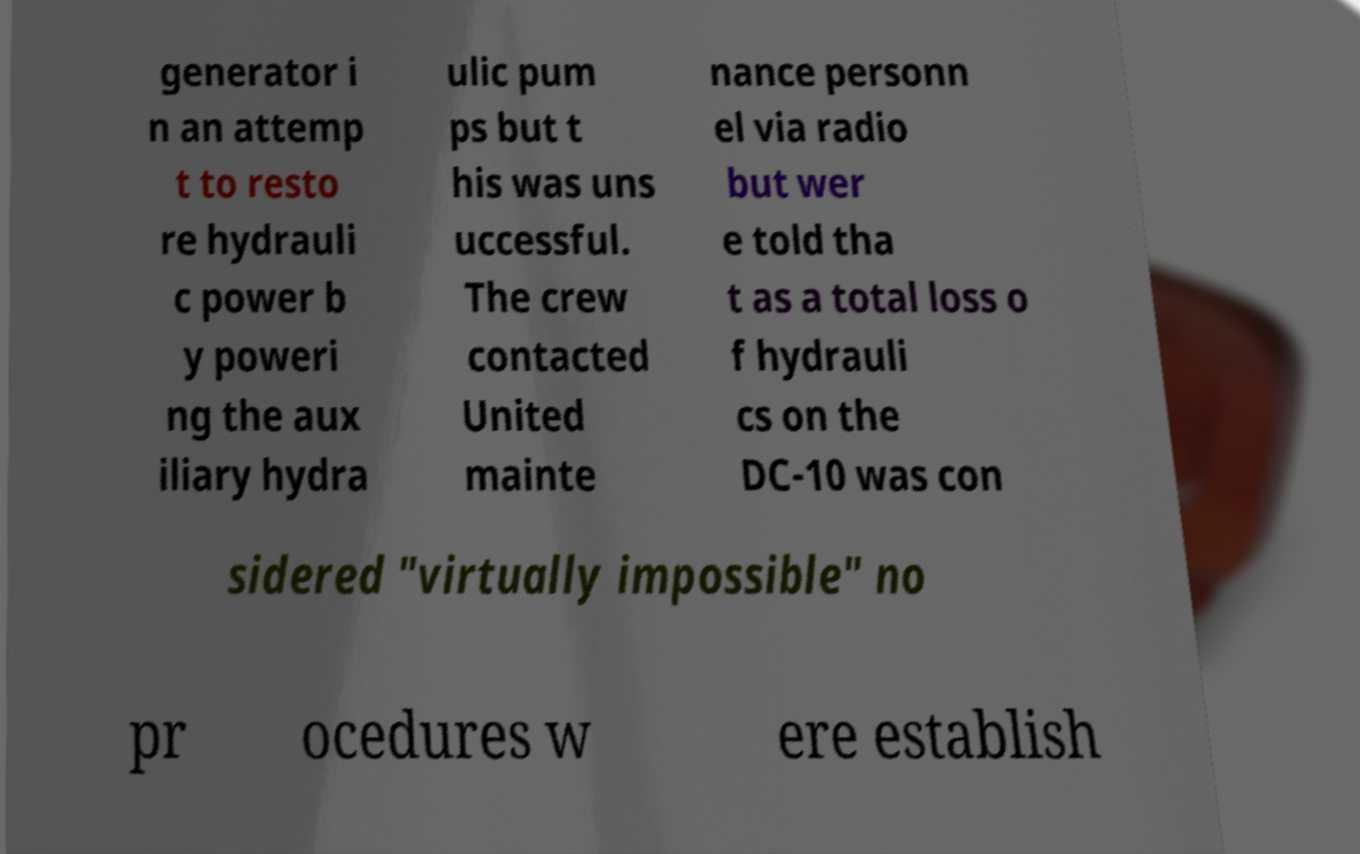Please identify and transcribe the text found in this image. generator i n an attemp t to resto re hydrauli c power b y poweri ng the aux iliary hydra ulic pum ps but t his was uns uccessful. The crew contacted United mainte nance personn el via radio but wer e told tha t as a total loss o f hydrauli cs on the DC-10 was con sidered "virtually impossible" no pr ocedures w ere establish 